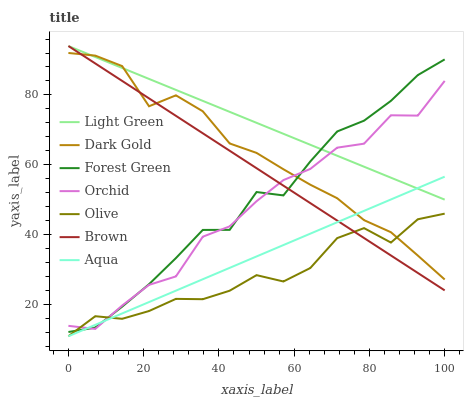Does Dark Gold have the minimum area under the curve?
Answer yes or no. No. Does Dark Gold have the maximum area under the curve?
Answer yes or no. No. Is Dark Gold the smoothest?
Answer yes or no. No. Is Dark Gold the roughest?
Answer yes or no. No. Does Dark Gold have the lowest value?
Answer yes or no. No. Does Dark Gold have the highest value?
Answer yes or no. No. Is Olive less than Light Green?
Answer yes or no. Yes. Is Light Green greater than Olive?
Answer yes or no. Yes. Does Olive intersect Light Green?
Answer yes or no. No. 